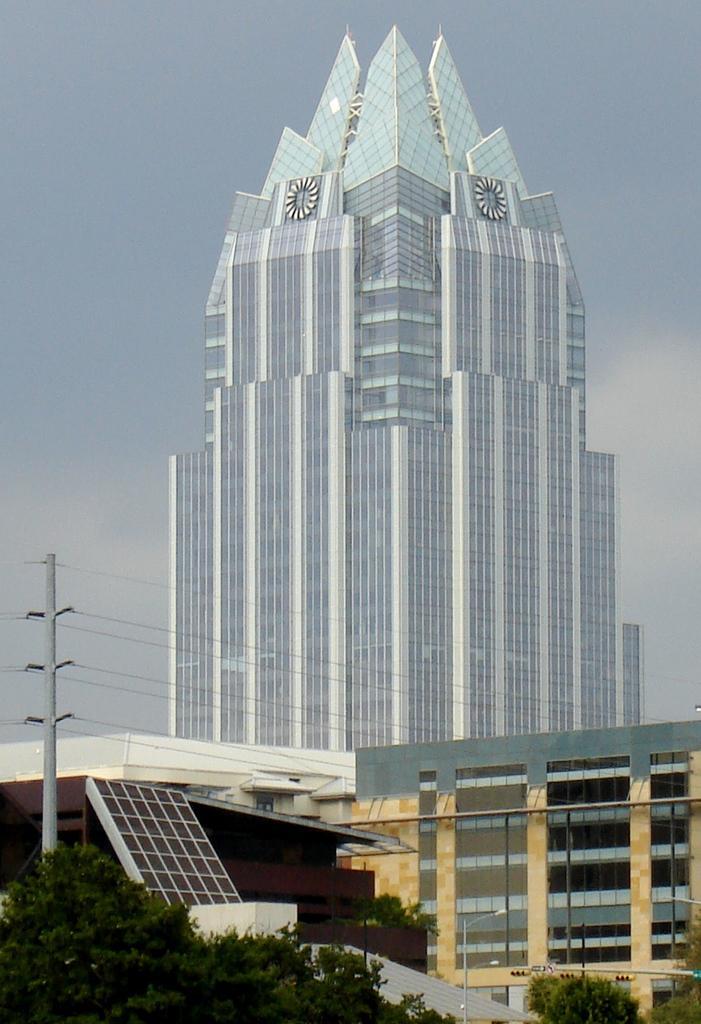Please provide a concise description of this image. In this image we can see some buildings with windows. We can also see a pole with some wires, a group of trees, a solar panel and the sky which looks cloudy. 